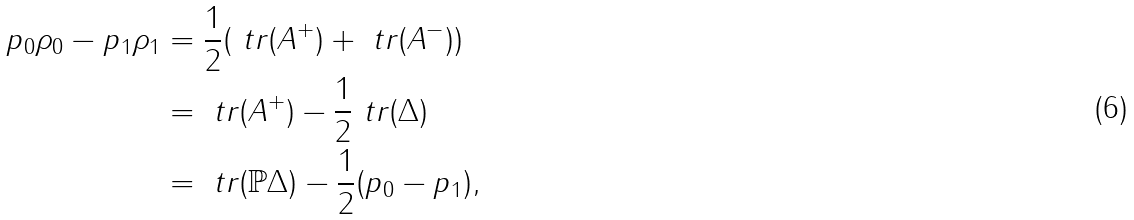Convert formula to latex. <formula><loc_0><loc_0><loc_500><loc_500>\| p _ { 0 } \rho _ { 0 } - p _ { 1 } \rho _ { 1 } \| & = \frac { 1 } { 2 } ( \ t r ( A ^ { + } ) + \ t r ( A ^ { - } ) ) \\ & = \ t r ( A ^ { + } ) - \frac { 1 } { 2 } \ t r ( \Delta ) \\ & = \ t r ( \mathbb { P } \Delta ) - \frac { 1 } { 2 } ( p _ { 0 } - p _ { 1 } ) ,</formula> 